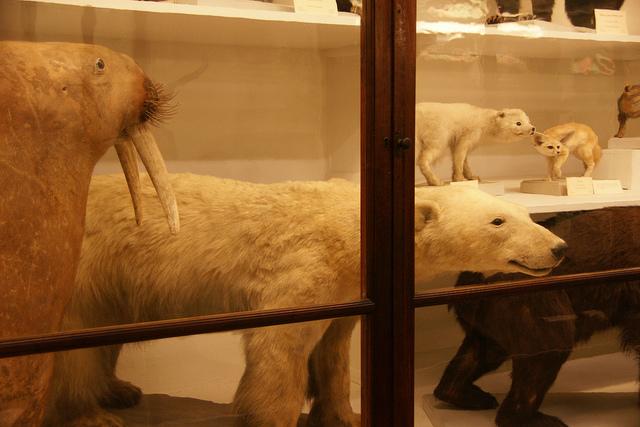Are these animals alive?
Give a very brief answer. No. How many types of animals are there?
Keep it brief. 4. Are these animals extinct?
Quick response, please. No. 